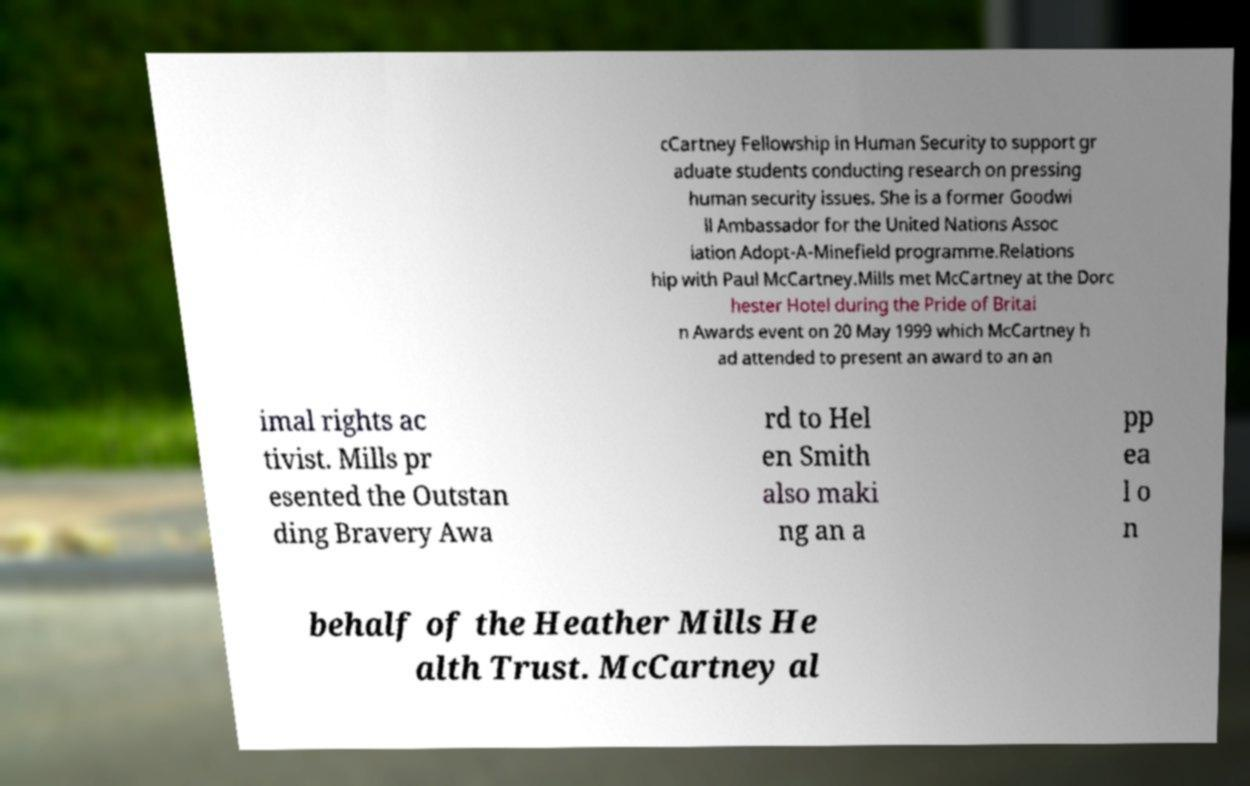Could you extract and type out the text from this image? cCartney Fellowship in Human Security to support gr aduate students conducting research on pressing human security issues. She is a former Goodwi ll Ambassador for the United Nations Assoc iation Adopt-A-Minefield programme.Relations hip with Paul McCartney.Mills met McCartney at the Dorc hester Hotel during the Pride of Britai n Awards event on 20 May 1999 which McCartney h ad attended to present an award to an an imal rights ac tivist. Mills pr esented the Outstan ding Bravery Awa rd to Hel en Smith also maki ng an a pp ea l o n behalf of the Heather Mills He alth Trust. McCartney al 